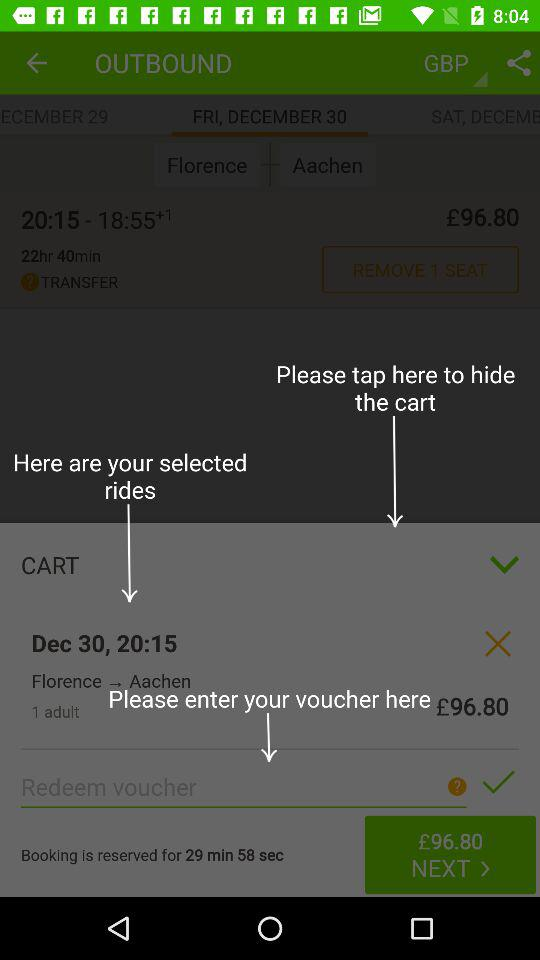What is the remaining time of the reserved booking? The remaining time of the reserved booking is 29 minutes 58 seconds. 